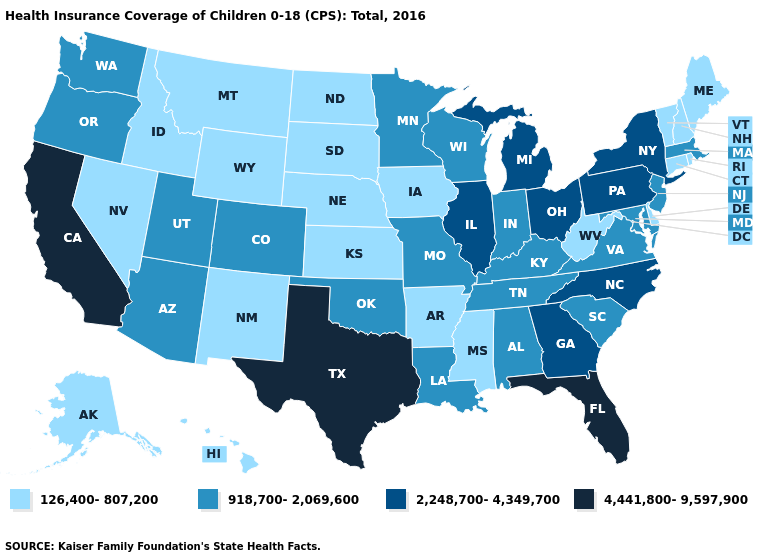Does Illinois have the highest value in the MidWest?
Write a very short answer. Yes. Among the states that border Massachusetts , does New York have the lowest value?
Be succinct. No. Does Indiana have the same value as Maryland?
Keep it brief. Yes. What is the highest value in states that border Texas?
Concise answer only. 918,700-2,069,600. Does the map have missing data?
Short answer required. No. Name the states that have a value in the range 4,441,800-9,597,900?
Give a very brief answer. California, Florida, Texas. What is the highest value in the South ?
Answer briefly. 4,441,800-9,597,900. What is the value of Maine?
Concise answer only. 126,400-807,200. Does Wyoming have a lower value than Massachusetts?
Answer briefly. Yes. Name the states that have a value in the range 126,400-807,200?
Write a very short answer. Alaska, Arkansas, Connecticut, Delaware, Hawaii, Idaho, Iowa, Kansas, Maine, Mississippi, Montana, Nebraska, Nevada, New Hampshire, New Mexico, North Dakota, Rhode Island, South Dakota, Vermont, West Virginia, Wyoming. What is the highest value in the USA?
Short answer required. 4,441,800-9,597,900. What is the value of New Jersey?
Quick response, please. 918,700-2,069,600. Which states have the lowest value in the USA?
Answer briefly. Alaska, Arkansas, Connecticut, Delaware, Hawaii, Idaho, Iowa, Kansas, Maine, Mississippi, Montana, Nebraska, Nevada, New Hampshire, New Mexico, North Dakota, Rhode Island, South Dakota, Vermont, West Virginia, Wyoming. 